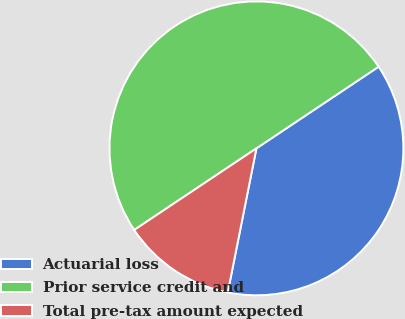Convert chart to OTSL. <chart><loc_0><loc_0><loc_500><loc_500><pie_chart><fcel>Actuarial loss<fcel>Prior service credit and<fcel>Total pre-tax amount expected<nl><fcel>37.5%<fcel>50.0%<fcel>12.5%<nl></chart> 